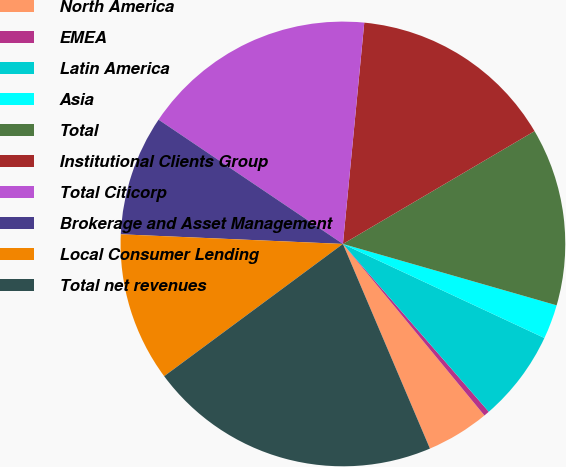<chart> <loc_0><loc_0><loc_500><loc_500><pie_chart><fcel>North America<fcel>EMEA<fcel>Latin America<fcel>Asia<fcel>Total<fcel>Institutional Clients Group<fcel>Total Citicorp<fcel>Brokerage and Asset Management<fcel>Local Consumer Lending<fcel>Total net revenues<nl><fcel>4.58%<fcel>0.41%<fcel>6.66%<fcel>2.5%<fcel>12.92%<fcel>15.0%<fcel>17.09%<fcel>8.75%<fcel>10.83%<fcel>21.26%<nl></chart> 